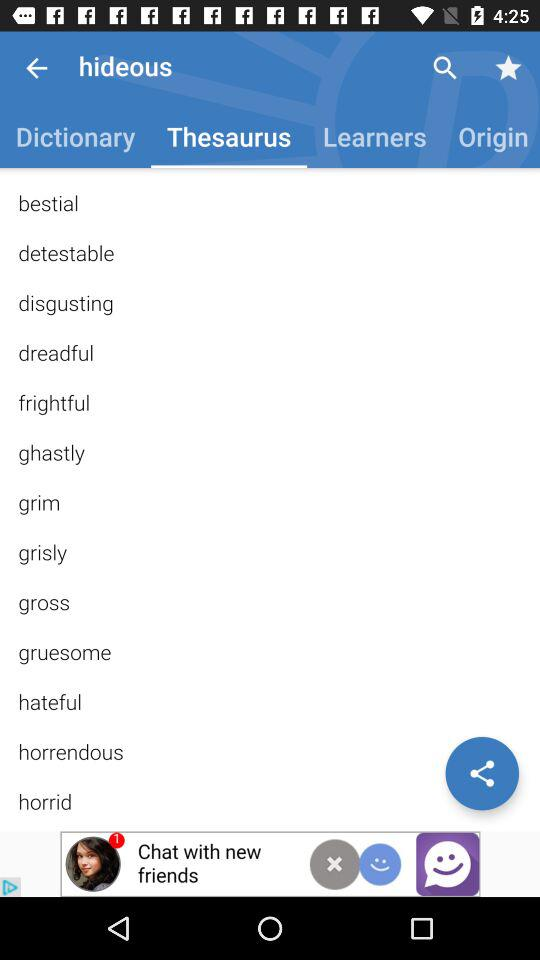What is the dictionary definition of "hideous"?
When the provided information is insufficient, respond with <no answer>. <no answer> 